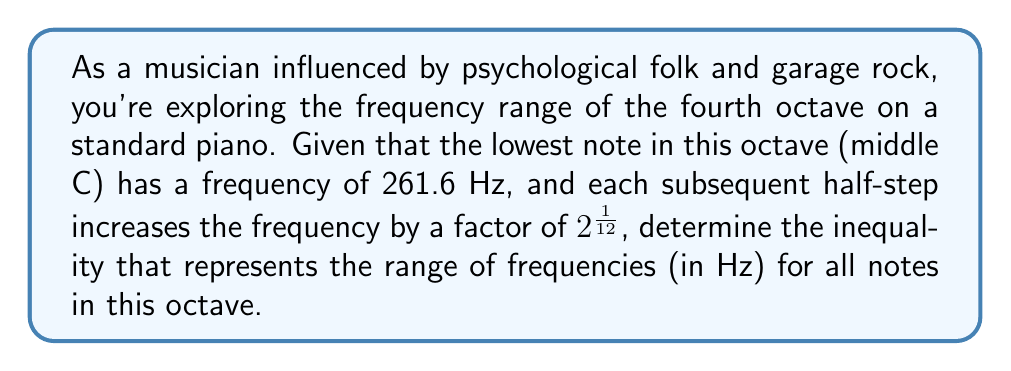Could you help me with this problem? Let's approach this step-by-step:

1) The fourth octave on a piano contains 12 half-steps, from middle C to the B above it.

2) The frequency of middle C is given as 261.6 Hz.

3) Each half-step increases the frequency by a factor of $2^{\frac{1}{12}}$.

4) To find the upper limit of the octave, we need to multiply 261.6 by $2^{\frac{1}{12}}$ twelve times:

   $261.6 \cdot (2^{\frac{1}{12}})^{12} = 261.6 \cdot 2 = 523.2$ Hz

5) Therefore, the range of frequencies in this octave is from 261.6 Hz to 523.2 Hz.

6) We can express this as an inequality:

   $261.6 \leq f \leq 523.2$

   where $f$ represents the frequency in Hz.
Answer: $261.6 \leq f \leq 523.2$ 